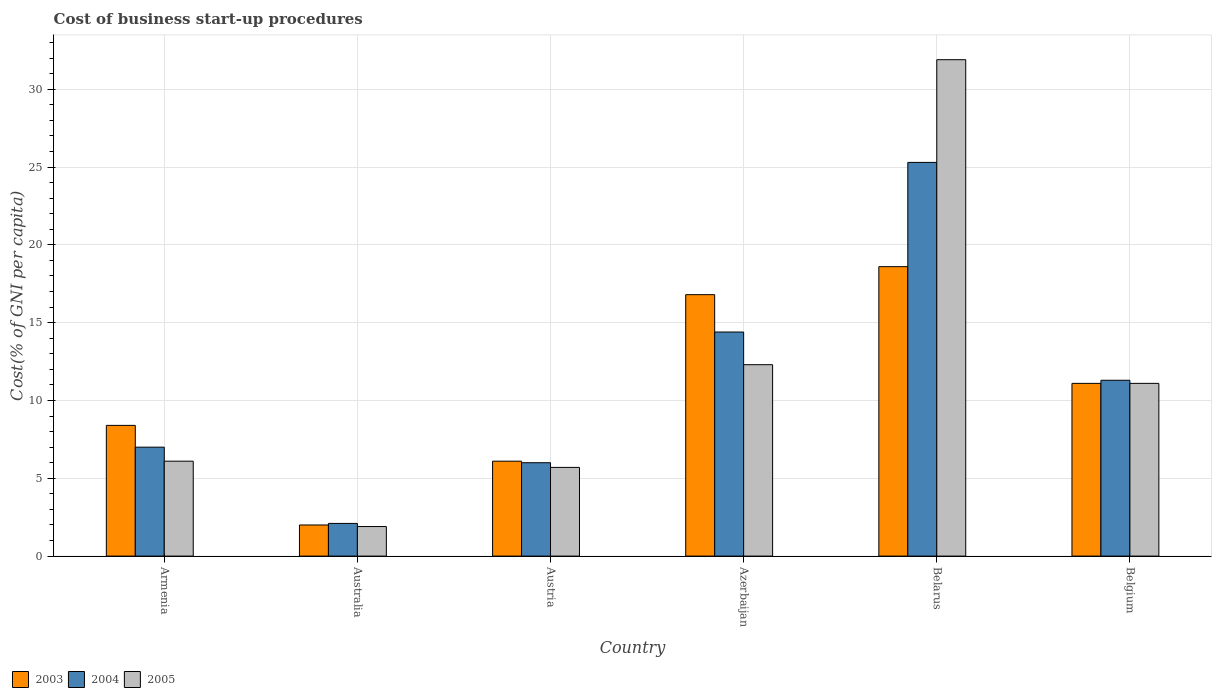Are the number of bars per tick equal to the number of legend labels?
Make the answer very short. Yes. Are the number of bars on each tick of the X-axis equal?
Offer a terse response. Yes. How many bars are there on the 1st tick from the left?
Offer a terse response. 3. How many bars are there on the 3rd tick from the right?
Provide a succinct answer. 3. What is the cost of business start-up procedures in 2004 in Belarus?
Provide a succinct answer. 25.3. Across all countries, what is the maximum cost of business start-up procedures in 2005?
Give a very brief answer. 31.9. Across all countries, what is the minimum cost of business start-up procedures in 2003?
Ensure brevity in your answer.  2. In which country was the cost of business start-up procedures in 2003 maximum?
Provide a short and direct response. Belarus. In which country was the cost of business start-up procedures in 2004 minimum?
Offer a very short reply. Australia. What is the total cost of business start-up procedures in 2004 in the graph?
Offer a terse response. 66.1. What is the difference between the cost of business start-up procedures in 2003 in Azerbaijan and that in Belgium?
Ensure brevity in your answer.  5.7. What is the average cost of business start-up procedures in 2004 per country?
Ensure brevity in your answer.  11.02. In how many countries, is the cost of business start-up procedures in 2003 greater than 7 %?
Your answer should be very brief. 4. What is the ratio of the cost of business start-up procedures in 2005 in Azerbaijan to that in Belarus?
Your answer should be very brief. 0.39. What is the difference between the highest and the second highest cost of business start-up procedures in 2003?
Provide a short and direct response. -1.8. In how many countries, is the cost of business start-up procedures in 2003 greater than the average cost of business start-up procedures in 2003 taken over all countries?
Your answer should be compact. 3. What does the 1st bar from the left in Austria represents?
Make the answer very short. 2003. Is it the case that in every country, the sum of the cost of business start-up procedures in 2005 and cost of business start-up procedures in 2004 is greater than the cost of business start-up procedures in 2003?
Ensure brevity in your answer.  Yes. How many bars are there?
Give a very brief answer. 18. Are the values on the major ticks of Y-axis written in scientific E-notation?
Offer a terse response. No. Does the graph contain any zero values?
Ensure brevity in your answer.  No. How many legend labels are there?
Provide a short and direct response. 3. What is the title of the graph?
Provide a short and direct response. Cost of business start-up procedures. What is the label or title of the Y-axis?
Offer a terse response. Cost(% of GNI per capita). What is the Cost(% of GNI per capita) of 2003 in Armenia?
Offer a terse response. 8.4. What is the Cost(% of GNI per capita) in 2005 in Armenia?
Provide a succinct answer. 6.1. What is the Cost(% of GNI per capita) of 2003 in Austria?
Provide a short and direct response. 6.1. What is the Cost(% of GNI per capita) in 2003 in Azerbaijan?
Offer a very short reply. 16.8. What is the Cost(% of GNI per capita) of 2005 in Azerbaijan?
Make the answer very short. 12.3. What is the Cost(% of GNI per capita) in 2003 in Belarus?
Provide a short and direct response. 18.6. What is the Cost(% of GNI per capita) in 2004 in Belarus?
Give a very brief answer. 25.3. What is the Cost(% of GNI per capita) of 2005 in Belarus?
Offer a very short reply. 31.9. What is the Cost(% of GNI per capita) in 2003 in Belgium?
Keep it short and to the point. 11.1. What is the Cost(% of GNI per capita) in 2004 in Belgium?
Your answer should be very brief. 11.3. What is the Cost(% of GNI per capita) of 2005 in Belgium?
Offer a very short reply. 11.1. Across all countries, what is the maximum Cost(% of GNI per capita) in 2004?
Your answer should be compact. 25.3. Across all countries, what is the maximum Cost(% of GNI per capita) in 2005?
Offer a very short reply. 31.9. Across all countries, what is the minimum Cost(% of GNI per capita) in 2003?
Offer a terse response. 2. Across all countries, what is the minimum Cost(% of GNI per capita) of 2005?
Your answer should be very brief. 1.9. What is the total Cost(% of GNI per capita) of 2004 in the graph?
Your response must be concise. 66.1. What is the total Cost(% of GNI per capita) of 2005 in the graph?
Your answer should be compact. 69. What is the difference between the Cost(% of GNI per capita) of 2004 in Armenia and that in Australia?
Offer a very short reply. 4.9. What is the difference between the Cost(% of GNI per capita) of 2005 in Armenia and that in Australia?
Your answer should be compact. 4.2. What is the difference between the Cost(% of GNI per capita) in 2003 in Armenia and that in Austria?
Offer a very short reply. 2.3. What is the difference between the Cost(% of GNI per capita) of 2004 in Armenia and that in Austria?
Make the answer very short. 1. What is the difference between the Cost(% of GNI per capita) of 2003 in Armenia and that in Azerbaijan?
Your response must be concise. -8.4. What is the difference between the Cost(% of GNI per capita) in 2003 in Armenia and that in Belarus?
Provide a short and direct response. -10.2. What is the difference between the Cost(% of GNI per capita) of 2004 in Armenia and that in Belarus?
Offer a terse response. -18.3. What is the difference between the Cost(% of GNI per capita) of 2005 in Armenia and that in Belarus?
Offer a very short reply. -25.8. What is the difference between the Cost(% of GNI per capita) in 2003 in Armenia and that in Belgium?
Provide a succinct answer. -2.7. What is the difference between the Cost(% of GNI per capita) of 2004 in Australia and that in Austria?
Provide a succinct answer. -3.9. What is the difference between the Cost(% of GNI per capita) in 2003 in Australia and that in Azerbaijan?
Offer a terse response. -14.8. What is the difference between the Cost(% of GNI per capita) in 2005 in Australia and that in Azerbaijan?
Offer a very short reply. -10.4. What is the difference between the Cost(% of GNI per capita) in 2003 in Australia and that in Belarus?
Provide a succinct answer. -16.6. What is the difference between the Cost(% of GNI per capita) in 2004 in Australia and that in Belarus?
Offer a very short reply. -23.2. What is the difference between the Cost(% of GNI per capita) in 2005 in Australia and that in Belgium?
Your answer should be very brief. -9.2. What is the difference between the Cost(% of GNI per capita) of 2003 in Austria and that in Azerbaijan?
Your answer should be very brief. -10.7. What is the difference between the Cost(% of GNI per capita) of 2004 in Austria and that in Azerbaijan?
Give a very brief answer. -8.4. What is the difference between the Cost(% of GNI per capita) in 2005 in Austria and that in Azerbaijan?
Your answer should be very brief. -6.6. What is the difference between the Cost(% of GNI per capita) of 2003 in Austria and that in Belarus?
Offer a terse response. -12.5. What is the difference between the Cost(% of GNI per capita) of 2004 in Austria and that in Belarus?
Make the answer very short. -19.3. What is the difference between the Cost(% of GNI per capita) of 2005 in Austria and that in Belarus?
Offer a terse response. -26.2. What is the difference between the Cost(% of GNI per capita) of 2003 in Azerbaijan and that in Belarus?
Your answer should be compact. -1.8. What is the difference between the Cost(% of GNI per capita) of 2005 in Azerbaijan and that in Belarus?
Give a very brief answer. -19.6. What is the difference between the Cost(% of GNI per capita) of 2003 in Belarus and that in Belgium?
Offer a very short reply. 7.5. What is the difference between the Cost(% of GNI per capita) of 2004 in Belarus and that in Belgium?
Your answer should be compact. 14. What is the difference between the Cost(% of GNI per capita) in 2005 in Belarus and that in Belgium?
Give a very brief answer. 20.8. What is the difference between the Cost(% of GNI per capita) of 2003 in Armenia and the Cost(% of GNI per capita) of 2004 in Australia?
Ensure brevity in your answer.  6.3. What is the difference between the Cost(% of GNI per capita) in 2003 in Armenia and the Cost(% of GNI per capita) in 2005 in Australia?
Keep it short and to the point. 6.5. What is the difference between the Cost(% of GNI per capita) of 2004 in Armenia and the Cost(% of GNI per capita) of 2005 in Australia?
Provide a succinct answer. 5.1. What is the difference between the Cost(% of GNI per capita) in 2003 in Armenia and the Cost(% of GNI per capita) in 2004 in Austria?
Your answer should be very brief. 2.4. What is the difference between the Cost(% of GNI per capita) in 2004 in Armenia and the Cost(% of GNI per capita) in 2005 in Austria?
Give a very brief answer. 1.3. What is the difference between the Cost(% of GNI per capita) in 2003 in Armenia and the Cost(% of GNI per capita) in 2004 in Azerbaijan?
Make the answer very short. -6. What is the difference between the Cost(% of GNI per capita) of 2003 in Armenia and the Cost(% of GNI per capita) of 2004 in Belarus?
Your answer should be compact. -16.9. What is the difference between the Cost(% of GNI per capita) of 2003 in Armenia and the Cost(% of GNI per capita) of 2005 in Belarus?
Your answer should be very brief. -23.5. What is the difference between the Cost(% of GNI per capita) in 2004 in Armenia and the Cost(% of GNI per capita) in 2005 in Belarus?
Your response must be concise. -24.9. What is the difference between the Cost(% of GNI per capita) in 2003 in Australia and the Cost(% of GNI per capita) in 2005 in Austria?
Your response must be concise. -3.7. What is the difference between the Cost(% of GNI per capita) in 2003 in Australia and the Cost(% of GNI per capita) in 2004 in Azerbaijan?
Make the answer very short. -12.4. What is the difference between the Cost(% of GNI per capita) of 2004 in Australia and the Cost(% of GNI per capita) of 2005 in Azerbaijan?
Your answer should be very brief. -10.2. What is the difference between the Cost(% of GNI per capita) in 2003 in Australia and the Cost(% of GNI per capita) in 2004 in Belarus?
Your answer should be compact. -23.3. What is the difference between the Cost(% of GNI per capita) of 2003 in Australia and the Cost(% of GNI per capita) of 2005 in Belarus?
Offer a very short reply. -29.9. What is the difference between the Cost(% of GNI per capita) in 2004 in Australia and the Cost(% of GNI per capita) in 2005 in Belarus?
Ensure brevity in your answer.  -29.8. What is the difference between the Cost(% of GNI per capita) in 2004 in Australia and the Cost(% of GNI per capita) in 2005 in Belgium?
Your answer should be compact. -9. What is the difference between the Cost(% of GNI per capita) in 2003 in Austria and the Cost(% of GNI per capita) in 2004 in Azerbaijan?
Offer a terse response. -8.3. What is the difference between the Cost(% of GNI per capita) of 2004 in Austria and the Cost(% of GNI per capita) of 2005 in Azerbaijan?
Give a very brief answer. -6.3. What is the difference between the Cost(% of GNI per capita) of 2003 in Austria and the Cost(% of GNI per capita) of 2004 in Belarus?
Ensure brevity in your answer.  -19.2. What is the difference between the Cost(% of GNI per capita) in 2003 in Austria and the Cost(% of GNI per capita) in 2005 in Belarus?
Give a very brief answer. -25.8. What is the difference between the Cost(% of GNI per capita) in 2004 in Austria and the Cost(% of GNI per capita) in 2005 in Belarus?
Your response must be concise. -25.9. What is the difference between the Cost(% of GNI per capita) of 2003 in Austria and the Cost(% of GNI per capita) of 2005 in Belgium?
Keep it short and to the point. -5. What is the difference between the Cost(% of GNI per capita) of 2004 in Austria and the Cost(% of GNI per capita) of 2005 in Belgium?
Offer a very short reply. -5.1. What is the difference between the Cost(% of GNI per capita) in 2003 in Azerbaijan and the Cost(% of GNI per capita) in 2005 in Belarus?
Keep it short and to the point. -15.1. What is the difference between the Cost(% of GNI per capita) of 2004 in Azerbaijan and the Cost(% of GNI per capita) of 2005 in Belarus?
Provide a short and direct response. -17.5. What is the difference between the Cost(% of GNI per capita) of 2003 in Belarus and the Cost(% of GNI per capita) of 2004 in Belgium?
Ensure brevity in your answer.  7.3. What is the difference between the Cost(% of GNI per capita) of 2003 in Belarus and the Cost(% of GNI per capita) of 2005 in Belgium?
Provide a short and direct response. 7.5. What is the average Cost(% of GNI per capita) in 2003 per country?
Provide a succinct answer. 10.5. What is the average Cost(% of GNI per capita) of 2004 per country?
Offer a very short reply. 11.02. What is the average Cost(% of GNI per capita) of 2005 per country?
Make the answer very short. 11.5. What is the difference between the Cost(% of GNI per capita) of 2003 and Cost(% of GNI per capita) of 2004 in Armenia?
Your answer should be very brief. 1.4. What is the difference between the Cost(% of GNI per capita) of 2003 and Cost(% of GNI per capita) of 2005 in Armenia?
Ensure brevity in your answer.  2.3. What is the difference between the Cost(% of GNI per capita) in 2004 and Cost(% of GNI per capita) in 2005 in Armenia?
Offer a very short reply. 0.9. What is the difference between the Cost(% of GNI per capita) of 2003 and Cost(% of GNI per capita) of 2005 in Australia?
Your response must be concise. 0.1. What is the difference between the Cost(% of GNI per capita) in 2004 and Cost(% of GNI per capita) in 2005 in Australia?
Make the answer very short. 0.2. What is the difference between the Cost(% of GNI per capita) in 2003 and Cost(% of GNI per capita) in 2005 in Austria?
Make the answer very short. 0.4. What is the difference between the Cost(% of GNI per capita) of 2004 and Cost(% of GNI per capita) of 2005 in Austria?
Make the answer very short. 0.3. What is the difference between the Cost(% of GNI per capita) in 2003 and Cost(% of GNI per capita) in 2005 in Azerbaijan?
Offer a terse response. 4.5. What is the difference between the Cost(% of GNI per capita) in 2003 and Cost(% of GNI per capita) in 2005 in Belarus?
Your answer should be compact. -13.3. What is the difference between the Cost(% of GNI per capita) of 2004 and Cost(% of GNI per capita) of 2005 in Belarus?
Your response must be concise. -6.6. What is the difference between the Cost(% of GNI per capita) of 2003 and Cost(% of GNI per capita) of 2005 in Belgium?
Your response must be concise. 0. What is the ratio of the Cost(% of GNI per capita) of 2003 in Armenia to that in Australia?
Offer a very short reply. 4.2. What is the ratio of the Cost(% of GNI per capita) of 2004 in Armenia to that in Australia?
Your answer should be very brief. 3.33. What is the ratio of the Cost(% of GNI per capita) in 2005 in Armenia to that in Australia?
Ensure brevity in your answer.  3.21. What is the ratio of the Cost(% of GNI per capita) of 2003 in Armenia to that in Austria?
Provide a succinct answer. 1.38. What is the ratio of the Cost(% of GNI per capita) in 2004 in Armenia to that in Austria?
Your answer should be compact. 1.17. What is the ratio of the Cost(% of GNI per capita) in 2005 in Armenia to that in Austria?
Offer a very short reply. 1.07. What is the ratio of the Cost(% of GNI per capita) of 2004 in Armenia to that in Azerbaijan?
Your response must be concise. 0.49. What is the ratio of the Cost(% of GNI per capita) in 2005 in Armenia to that in Azerbaijan?
Offer a terse response. 0.5. What is the ratio of the Cost(% of GNI per capita) in 2003 in Armenia to that in Belarus?
Your answer should be compact. 0.45. What is the ratio of the Cost(% of GNI per capita) of 2004 in Armenia to that in Belarus?
Make the answer very short. 0.28. What is the ratio of the Cost(% of GNI per capita) of 2005 in Armenia to that in Belarus?
Offer a terse response. 0.19. What is the ratio of the Cost(% of GNI per capita) of 2003 in Armenia to that in Belgium?
Make the answer very short. 0.76. What is the ratio of the Cost(% of GNI per capita) in 2004 in Armenia to that in Belgium?
Give a very brief answer. 0.62. What is the ratio of the Cost(% of GNI per capita) of 2005 in Armenia to that in Belgium?
Your answer should be compact. 0.55. What is the ratio of the Cost(% of GNI per capita) of 2003 in Australia to that in Austria?
Offer a very short reply. 0.33. What is the ratio of the Cost(% of GNI per capita) of 2004 in Australia to that in Austria?
Provide a succinct answer. 0.35. What is the ratio of the Cost(% of GNI per capita) of 2005 in Australia to that in Austria?
Your response must be concise. 0.33. What is the ratio of the Cost(% of GNI per capita) of 2003 in Australia to that in Azerbaijan?
Offer a very short reply. 0.12. What is the ratio of the Cost(% of GNI per capita) of 2004 in Australia to that in Azerbaijan?
Ensure brevity in your answer.  0.15. What is the ratio of the Cost(% of GNI per capita) of 2005 in Australia to that in Azerbaijan?
Offer a terse response. 0.15. What is the ratio of the Cost(% of GNI per capita) of 2003 in Australia to that in Belarus?
Keep it short and to the point. 0.11. What is the ratio of the Cost(% of GNI per capita) of 2004 in Australia to that in Belarus?
Offer a terse response. 0.08. What is the ratio of the Cost(% of GNI per capita) of 2005 in Australia to that in Belarus?
Your answer should be very brief. 0.06. What is the ratio of the Cost(% of GNI per capita) of 2003 in Australia to that in Belgium?
Ensure brevity in your answer.  0.18. What is the ratio of the Cost(% of GNI per capita) of 2004 in Australia to that in Belgium?
Your answer should be very brief. 0.19. What is the ratio of the Cost(% of GNI per capita) in 2005 in Australia to that in Belgium?
Keep it short and to the point. 0.17. What is the ratio of the Cost(% of GNI per capita) of 2003 in Austria to that in Azerbaijan?
Your response must be concise. 0.36. What is the ratio of the Cost(% of GNI per capita) in 2004 in Austria to that in Azerbaijan?
Provide a succinct answer. 0.42. What is the ratio of the Cost(% of GNI per capita) of 2005 in Austria to that in Azerbaijan?
Your response must be concise. 0.46. What is the ratio of the Cost(% of GNI per capita) of 2003 in Austria to that in Belarus?
Provide a short and direct response. 0.33. What is the ratio of the Cost(% of GNI per capita) of 2004 in Austria to that in Belarus?
Offer a terse response. 0.24. What is the ratio of the Cost(% of GNI per capita) of 2005 in Austria to that in Belarus?
Keep it short and to the point. 0.18. What is the ratio of the Cost(% of GNI per capita) of 2003 in Austria to that in Belgium?
Your response must be concise. 0.55. What is the ratio of the Cost(% of GNI per capita) in 2004 in Austria to that in Belgium?
Provide a succinct answer. 0.53. What is the ratio of the Cost(% of GNI per capita) in 2005 in Austria to that in Belgium?
Your answer should be compact. 0.51. What is the ratio of the Cost(% of GNI per capita) of 2003 in Azerbaijan to that in Belarus?
Your answer should be compact. 0.9. What is the ratio of the Cost(% of GNI per capita) of 2004 in Azerbaijan to that in Belarus?
Keep it short and to the point. 0.57. What is the ratio of the Cost(% of GNI per capita) in 2005 in Azerbaijan to that in Belarus?
Ensure brevity in your answer.  0.39. What is the ratio of the Cost(% of GNI per capita) of 2003 in Azerbaijan to that in Belgium?
Keep it short and to the point. 1.51. What is the ratio of the Cost(% of GNI per capita) of 2004 in Azerbaijan to that in Belgium?
Offer a very short reply. 1.27. What is the ratio of the Cost(% of GNI per capita) of 2005 in Azerbaijan to that in Belgium?
Make the answer very short. 1.11. What is the ratio of the Cost(% of GNI per capita) in 2003 in Belarus to that in Belgium?
Make the answer very short. 1.68. What is the ratio of the Cost(% of GNI per capita) of 2004 in Belarus to that in Belgium?
Your response must be concise. 2.24. What is the ratio of the Cost(% of GNI per capita) in 2005 in Belarus to that in Belgium?
Give a very brief answer. 2.87. What is the difference between the highest and the second highest Cost(% of GNI per capita) of 2003?
Provide a short and direct response. 1.8. What is the difference between the highest and the second highest Cost(% of GNI per capita) in 2004?
Offer a terse response. 10.9. What is the difference between the highest and the second highest Cost(% of GNI per capita) of 2005?
Provide a short and direct response. 19.6. What is the difference between the highest and the lowest Cost(% of GNI per capita) in 2003?
Offer a terse response. 16.6. What is the difference between the highest and the lowest Cost(% of GNI per capita) of 2004?
Your response must be concise. 23.2. What is the difference between the highest and the lowest Cost(% of GNI per capita) in 2005?
Make the answer very short. 30. 